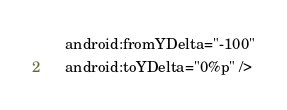Convert code to text. <code><loc_0><loc_0><loc_500><loc_500><_XML_>    android:fromYDelta="-100"
    android:toYDelta="0%p" /></code> 